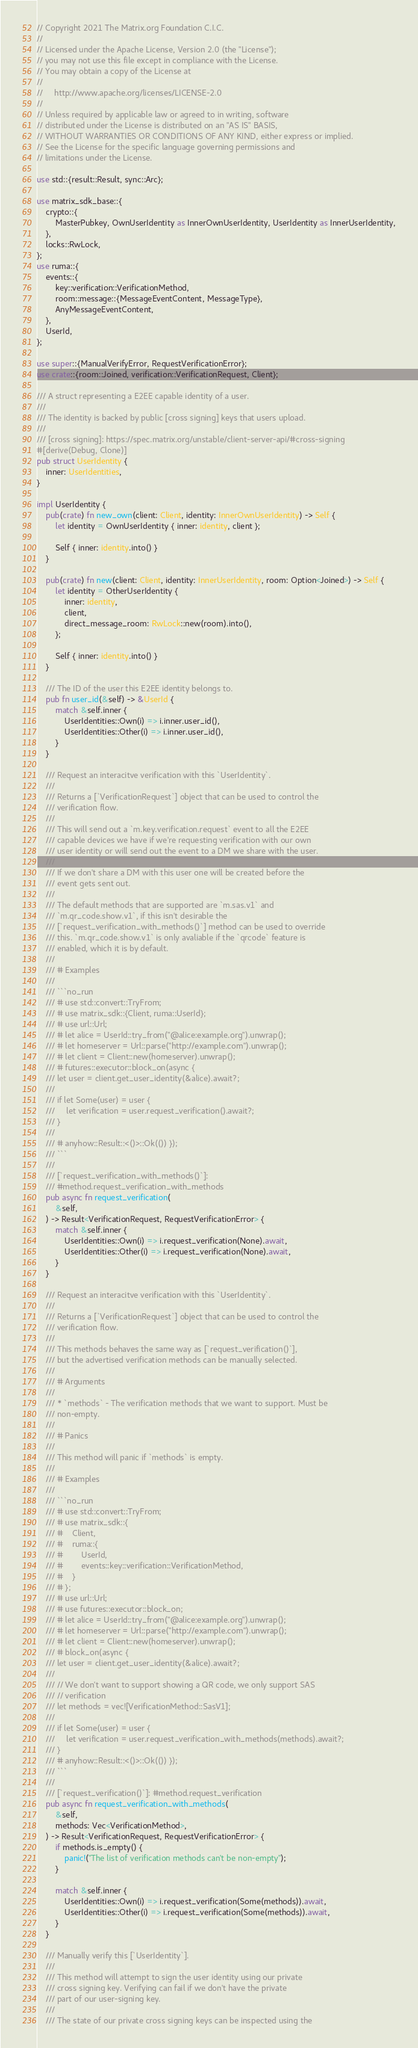<code> <loc_0><loc_0><loc_500><loc_500><_Rust_>// Copyright 2021 The Matrix.org Foundation C.I.C.
//
// Licensed under the Apache License, Version 2.0 (the "License");
// you may not use this file except in compliance with the License.
// You may obtain a copy of the License at
//
//     http://www.apache.org/licenses/LICENSE-2.0
//
// Unless required by applicable law or agreed to in writing, software
// distributed under the License is distributed on an "AS IS" BASIS,
// WITHOUT WARRANTIES OR CONDITIONS OF ANY KIND, either express or implied.
// See the License for the specific language governing permissions and
// limitations under the License.

use std::{result::Result, sync::Arc};

use matrix_sdk_base::{
    crypto::{
        MasterPubkey, OwnUserIdentity as InnerOwnUserIdentity, UserIdentity as InnerUserIdentity,
    },
    locks::RwLock,
};
use ruma::{
    events::{
        key::verification::VerificationMethod,
        room::message::{MessageEventContent, MessageType},
        AnyMessageEventContent,
    },
    UserId,
};

use super::{ManualVerifyError, RequestVerificationError};
use crate::{room::Joined, verification::VerificationRequest, Client};

/// A struct representing a E2EE capable identity of a user.
///
/// The identity is backed by public [cross signing] keys that users upload.
///
/// [cross signing]: https://spec.matrix.org/unstable/client-server-api/#cross-signing
#[derive(Debug, Clone)]
pub struct UserIdentity {
    inner: UserIdentities,
}

impl UserIdentity {
    pub(crate) fn new_own(client: Client, identity: InnerOwnUserIdentity) -> Self {
        let identity = OwnUserIdentity { inner: identity, client };

        Self { inner: identity.into() }
    }

    pub(crate) fn new(client: Client, identity: InnerUserIdentity, room: Option<Joined>) -> Self {
        let identity = OtherUserIdentity {
            inner: identity,
            client,
            direct_message_room: RwLock::new(room).into(),
        };

        Self { inner: identity.into() }
    }

    /// The ID of the user this E2EE identity belongs to.
    pub fn user_id(&self) -> &UserId {
        match &self.inner {
            UserIdentities::Own(i) => i.inner.user_id(),
            UserIdentities::Other(i) => i.inner.user_id(),
        }
    }

    /// Request an interacitve verification with this `UserIdentity`.
    ///
    /// Returns a [`VerificationRequest`] object that can be used to control the
    /// verification flow.
    ///
    /// This will send out a `m.key.verification.request` event to all the E2EE
    /// capable devices we have if we're requesting verification with our own
    /// user identity or will send out the event to a DM we share with the user.
    ///
    /// If we don't share a DM with this user one will be created before the
    /// event gets sent out.
    ///
    /// The default methods that are supported are `m.sas.v1` and
    /// `m.qr_code.show.v1`, if this isn't desirable the
    /// [`request_verification_with_methods()`] method can be used to override
    /// this. `m.qr_code.show.v1` is only avaliable if the `qrcode` feature is
    /// enabled, which it is by default.
    ///
    /// # Examples
    ///
    /// ```no_run
    /// # use std::convert::TryFrom;
    /// # use matrix_sdk::{Client, ruma::UserId};
    /// # use url::Url;
    /// # let alice = UserId::try_from("@alice:example.org").unwrap();
    /// # let homeserver = Url::parse("http://example.com").unwrap();
    /// # let client = Client::new(homeserver).unwrap();
    /// # futures::executor::block_on(async {
    /// let user = client.get_user_identity(&alice).await?;
    ///
    /// if let Some(user) = user {
    ///     let verification = user.request_verification().await?;
    /// }
    ///
    /// # anyhow::Result::<()>::Ok(()) });
    /// ```
    ///
    /// [`request_verification_with_methods()`]:
    /// #method.request_verification_with_methods
    pub async fn request_verification(
        &self,
    ) -> Result<VerificationRequest, RequestVerificationError> {
        match &self.inner {
            UserIdentities::Own(i) => i.request_verification(None).await,
            UserIdentities::Other(i) => i.request_verification(None).await,
        }
    }

    /// Request an interacitve verification with this `UserIdentity`.
    ///
    /// Returns a [`VerificationRequest`] object that can be used to control the
    /// verification flow.
    ///
    /// This methods behaves the same way as [`request_verification()`],
    /// but the advertised verification methods can be manually selected.
    ///
    /// # Arguments
    ///
    /// * `methods` - The verification methods that we want to support. Must be
    /// non-empty.
    ///
    /// # Panics
    ///
    /// This method will panic if `methods` is empty.
    ///
    /// # Examples
    ///
    /// ```no_run
    /// # use std::convert::TryFrom;
    /// # use matrix_sdk::{
    /// #    Client,
    /// #    ruma::{
    /// #        UserId,
    /// #        events::key::verification::VerificationMethod,
    /// #    }
    /// # };
    /// # use url::Url;
    /// # use futures::executor::block_on;
    /// # let alice = UserId::try_from("@alice:example.org").unwrap();
    /// # let homeserver = Url::parse("http://example.com").unwrap();
    /// # let client = Client::new(homeserver).unwrap();
    /// # block_on(async {
    /// let user = client.get_user_identity(&alice).await?;
    ///
    /// // We don't want to support showing a QR code, we only support SAS
    /// // verification
    /// let methods = vec![VerificationMethod::SasV1];
    ///
    /// if let Some(user) = user {
    ///     let verification = user.request_verification_with_methods(methods).await?;
    /// }
    /// # anyhow::Result::<()>::Ok(()) });
    /// ```
    ///
    /// [`request_verification()`]: #method.request_verification
    pub async fn request_verification_with_methods(
        &self,
        methods: Vec<VerificationMethod>,
    ) -> Result<VerificationRequest, RequestVerificationError> {
        if methods.is_empty() {
            panic!("The list of verification methods can't be non-empty");
        }

        match &self.inner {
            UserIdentities::Own(i) => i.request_verification(Some(methods)).await,
            UserIdentities::Other(i) => i.request_verification(Some(methods)).await,
        }
    }

    /// Manually verify this [`UserIdentity`].
    ///
    /// This method will attempt to sign the user identity using our private
    /// cross signing key. Verifying can fail if we don't have the private
    /// part of our user-signing key.
    ///
    /// The state of our private cross signing keys can be inspected using the</code> 